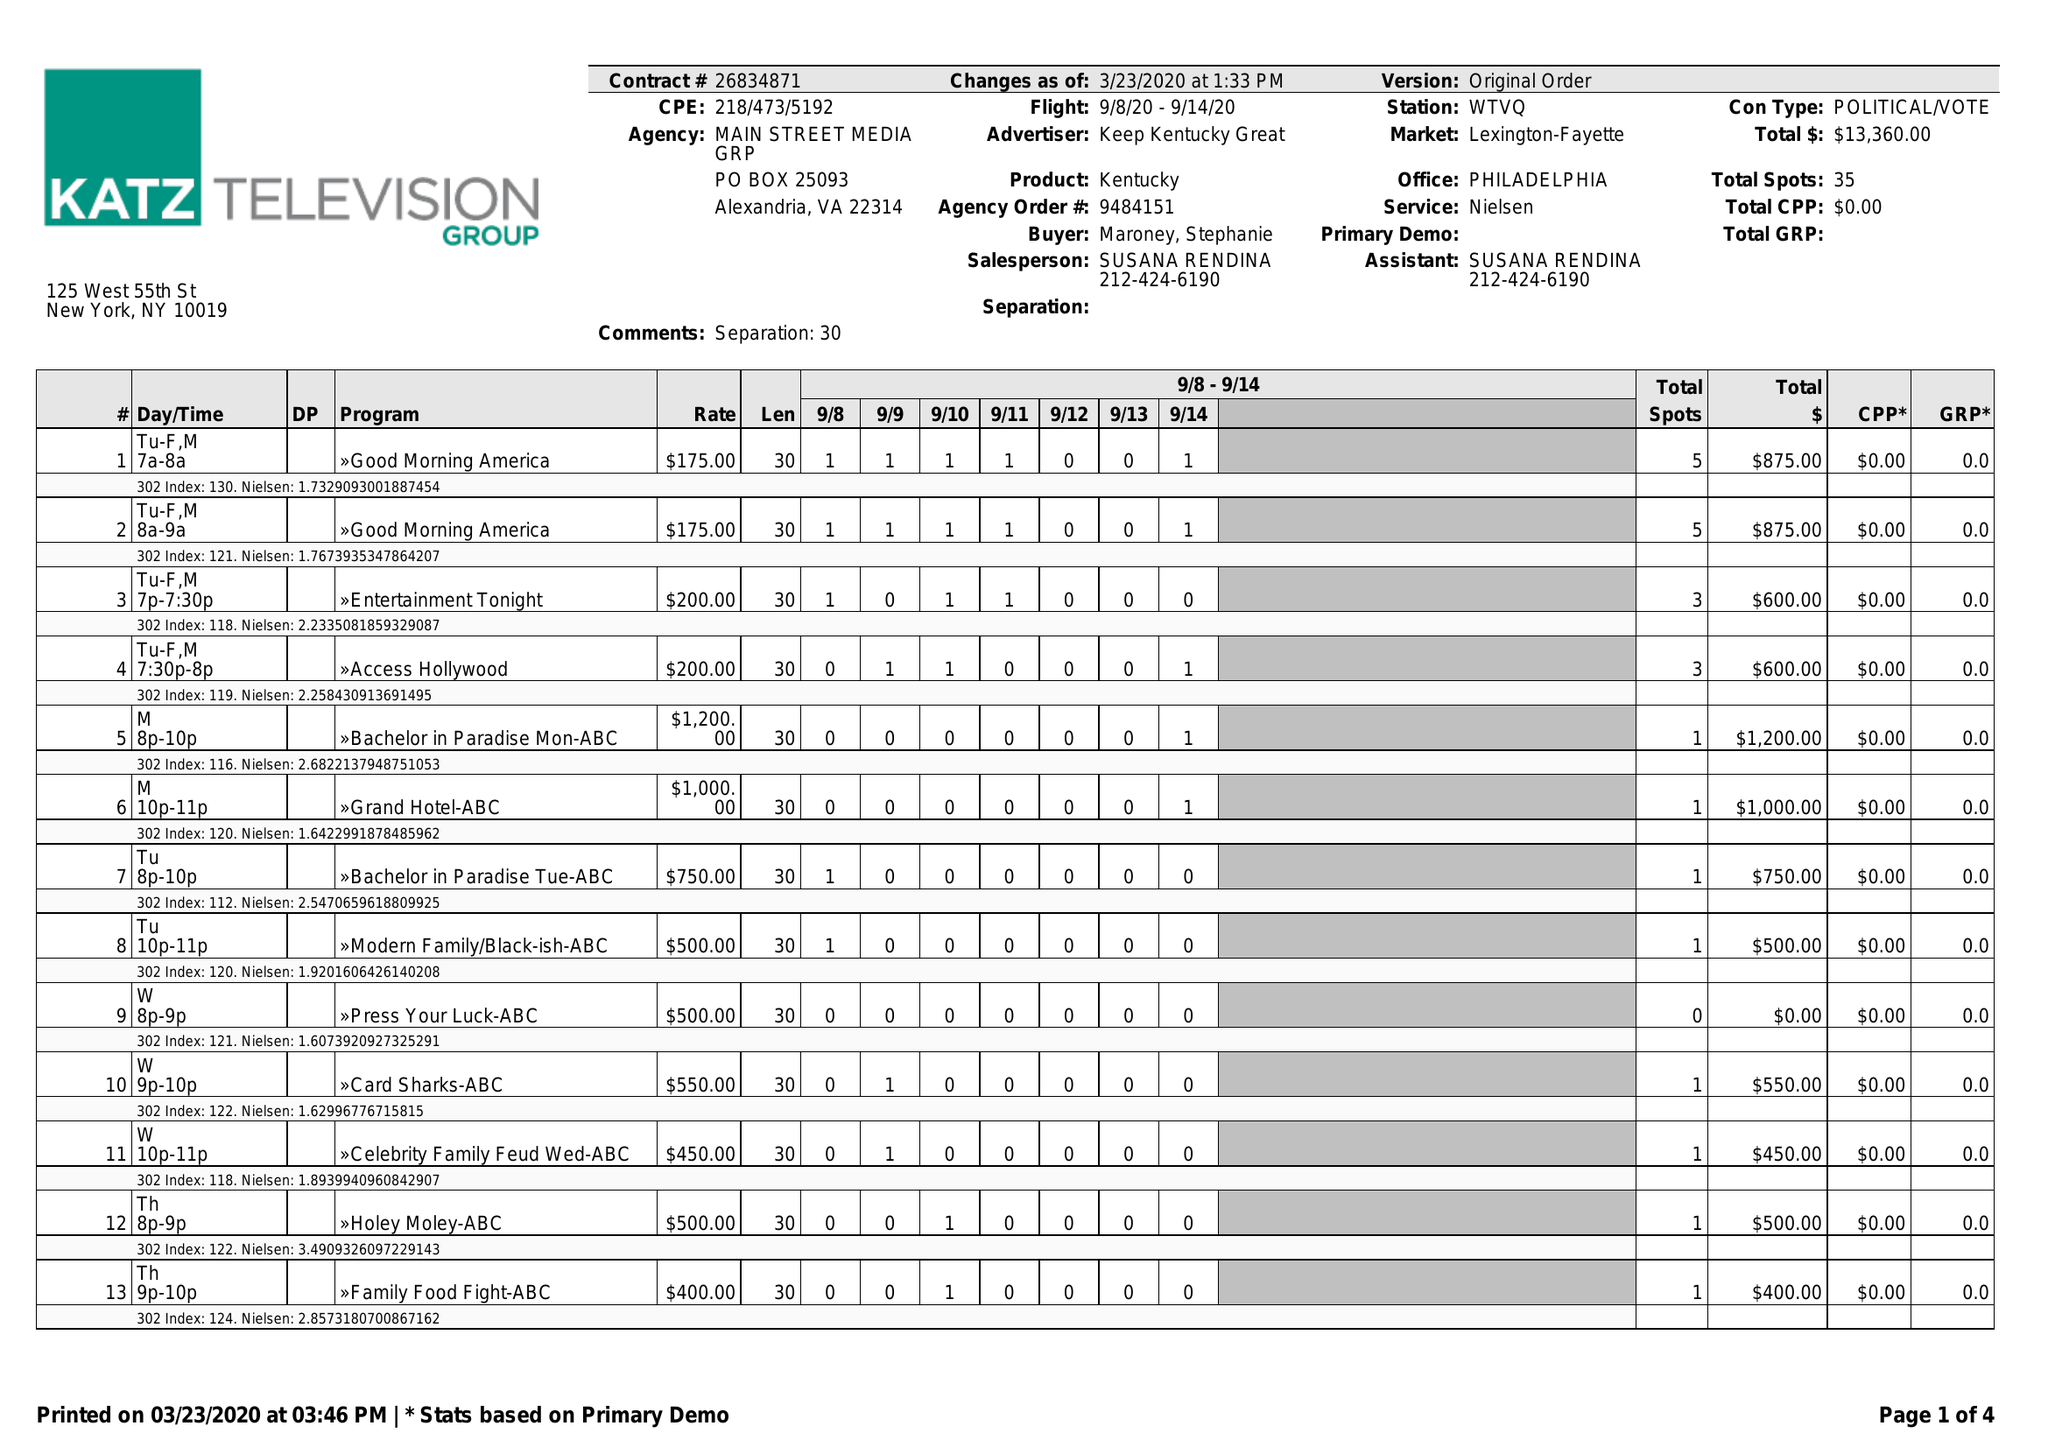What is the value for the gross_amount?
Answer the question using a single word or phrase. 13360.00 